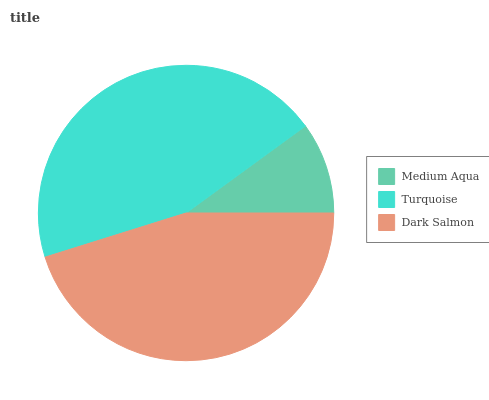Is Medium Aqua the minimum?
Answer yes or no. Yes. Is Dark Salmon the maximum?
Answer yes or no. Yes. Is Turquoise the minimum?
Answer yes or no. No. Is Turquoise the maximum?
Answer yes or no. No. Is Turquoise greater than Medium Aqua?
Answer yes or no. Yes. Is Medium Aqua less than Turquoise?
Answer yes or no. Yes. Is Medium Aqua greater than Turquoise?
Answer yes or no. No. Is Turquoise less than Medium Aqua?
Answer yes or no. No. Is Turquoise the high median?
Answer yes or no. Yes. Is Turquoise the low median?
Answer yes or no. Yes. Is Dark Salmon the high median?
Answer yes or no. No. Is Medium Aqua the low median?
Answer yes or no. No. 